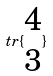Convert formula to latex. <formula><loc_0><loc_0><loc_500><loc_500>t r \{ \begin{matrix} 4 \\ 3 \end{matrix} \}</formula> 